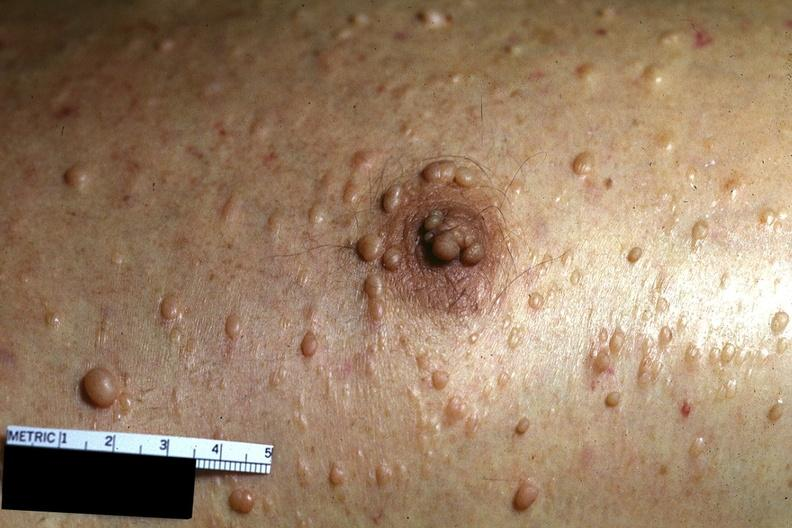what does this image show?
Answer the question using a single word or phrase. Skin 